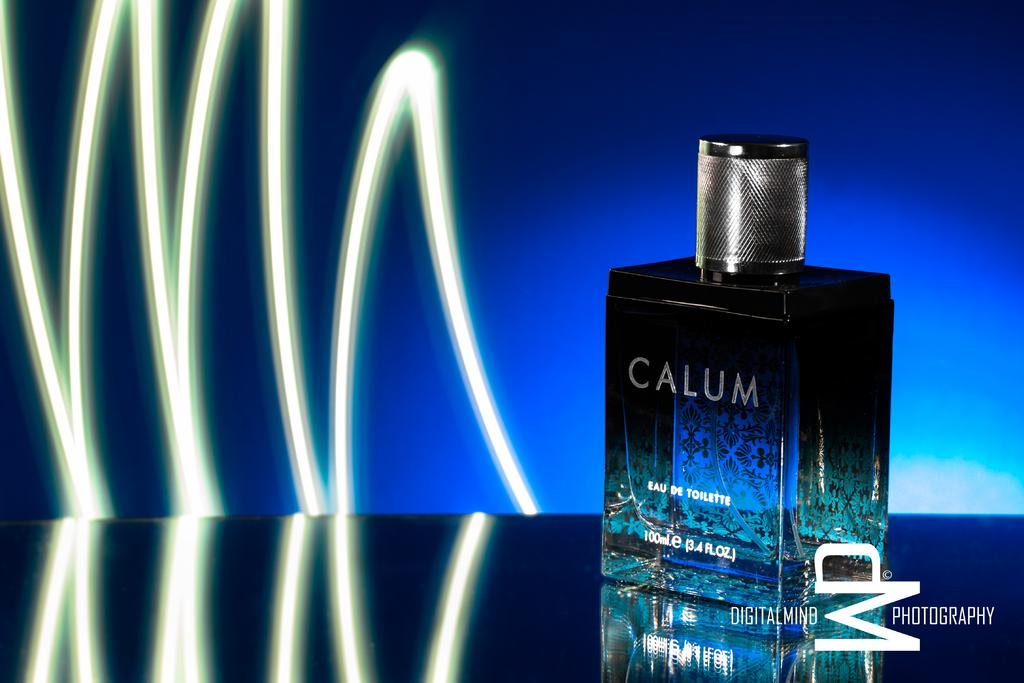<image>
Share a concise interpretation of the image provided. A blue bottle of Calum cologne is sitting on a blue table in front of a blue wall. 